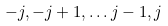<formula> <loc_0><loc_0><loc_500><loc_500>- j , - j + 1 , \dots j - 1 , j</formula> 